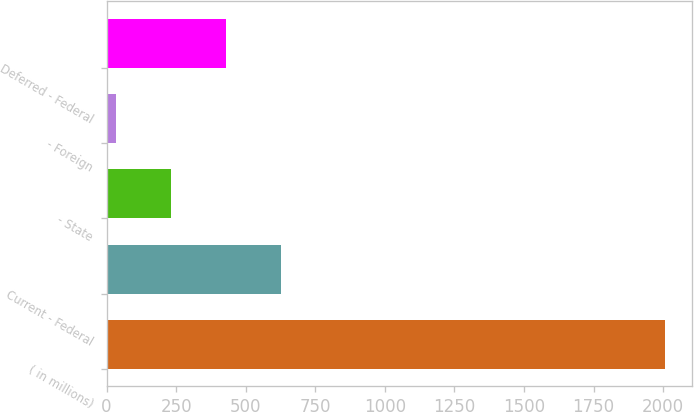Convert chart. <chart><loc_0><loc_0><loc_500><loc_500><bar_chart><fcel>( in millions)<fcel>Current - Federal<fcel>- State<fcel>- Foreign<fcel>Deferred - Federal<nl><fcel>2005<fcel>626<fcel>232<fcel>35<fcel>429<nl></chart> 